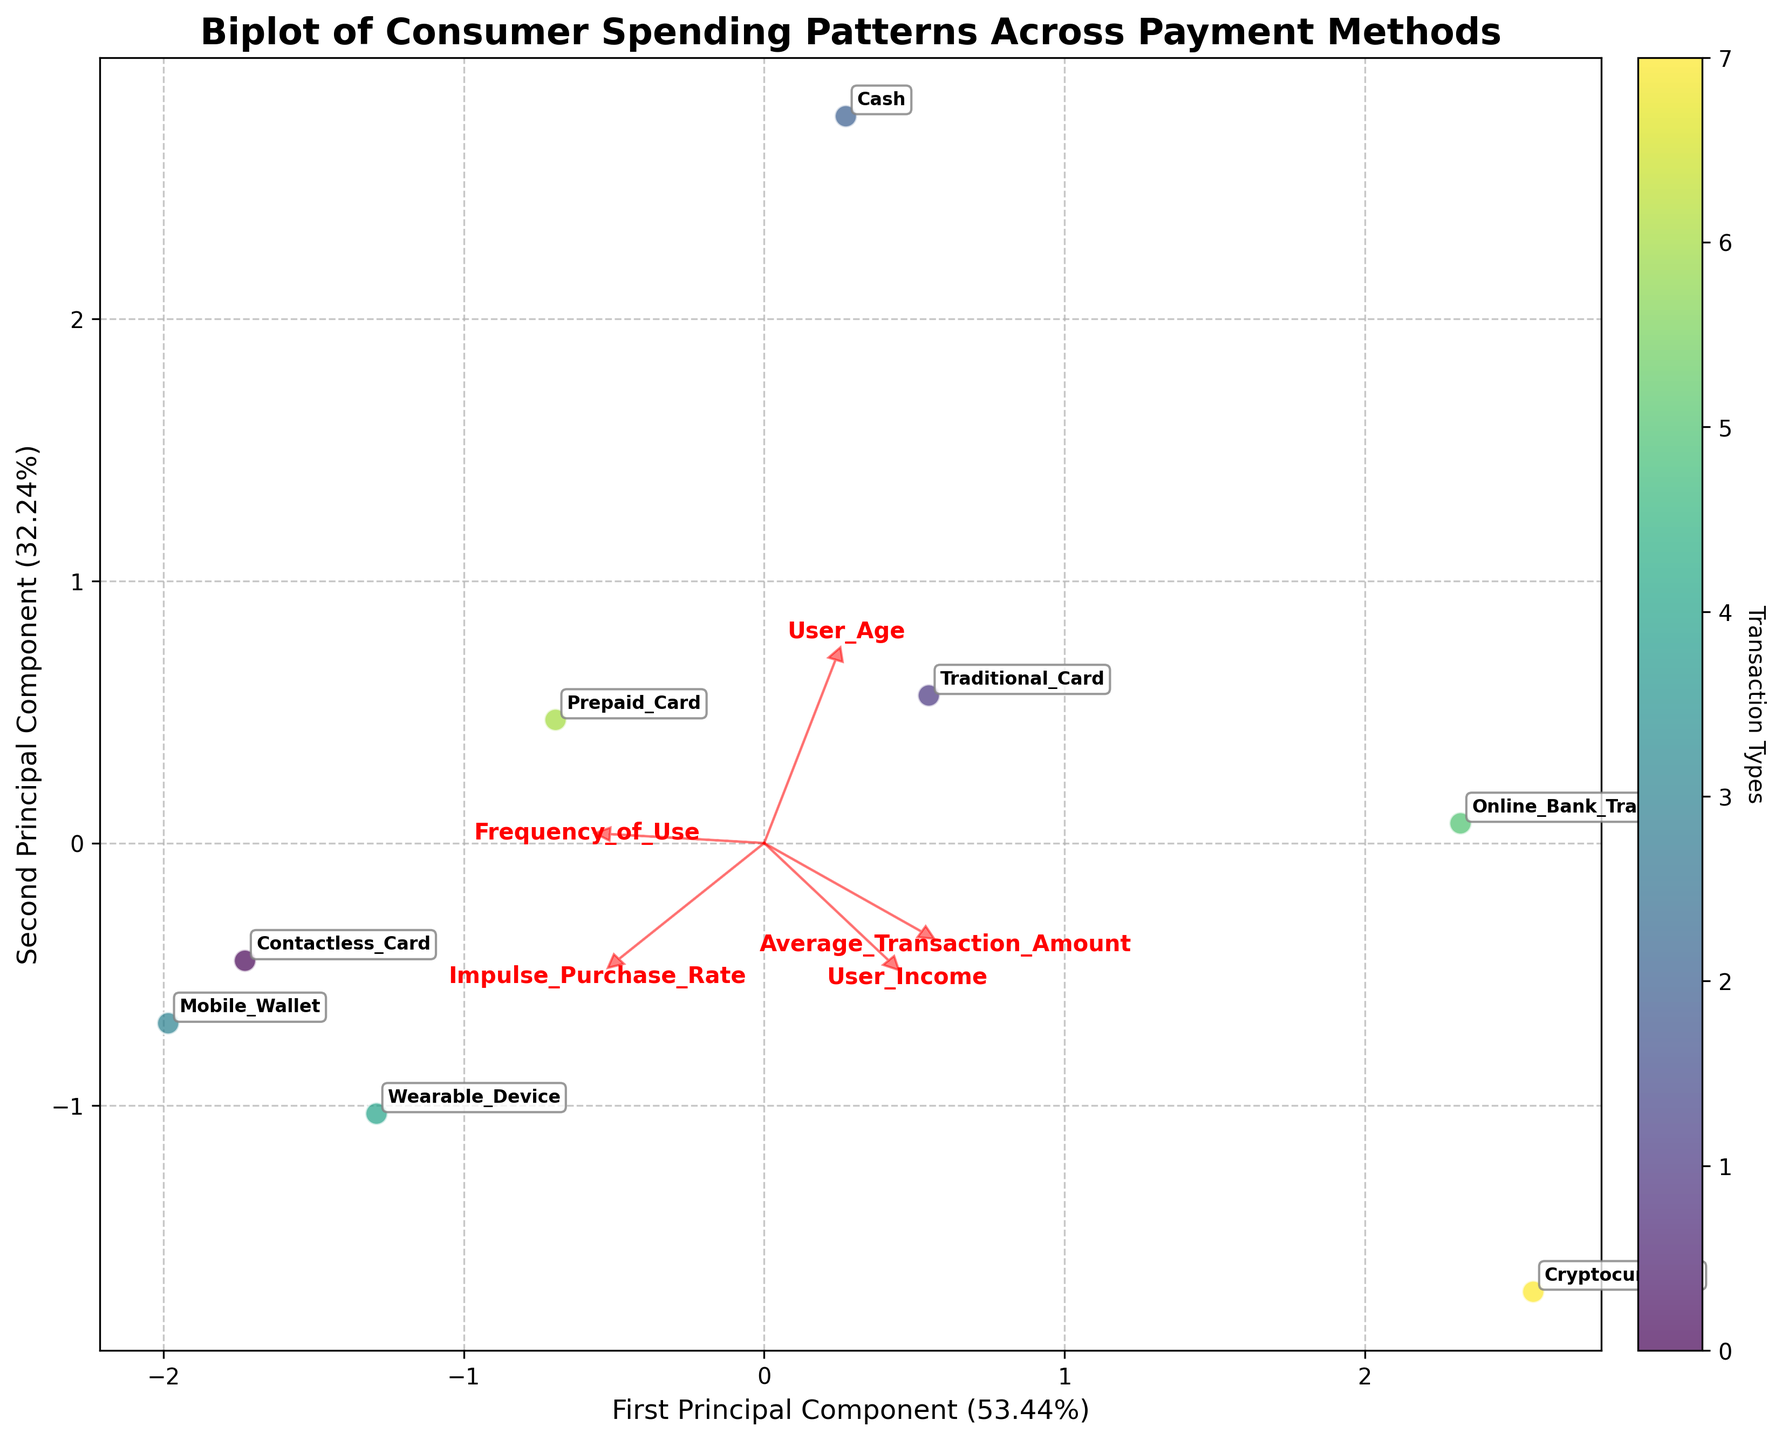How many principal components are displayed in the biplot? The biplot shows two principal components, which is evident from the two axes labeled as 'First Principal Component' and 'Second Principal Component'.
Answer: Two Which payment method has the highest value on the first principal component? To find the payment method with the highest value on the first principal component, look at the x-axis for the furthest point to the right.
Answer: Cryptocurrency What is the range of the impulse purchase rate based on the feature vectors in the biplot? The impulse purchase rate vector originates from the center and points in a specific direction. Observing the length and direction gives an idea of the range covered by the vector.
Answer: From -0.35 to 0.35 Which two payment methods have the smallest Euclidean distance between their principal component scores? Check the proximity of the points representing different payment methods. The pairs of points closest to each other represent those with the smallest Euclidean distance.
Answer: Contactless Card and Mobile Wallet How does user age correlate with the first principal component? Correlation can be inferred from the direction and proximity of the user age feature vector relative to the first principal component axis.
Answer: Inversely related Between contactless card and traditional card, which has a higher frequency of use? Locate the points for contactless card and traditional card. Then, refer to the frequency of use feature vector to see which point aligns more closely with a higher value.
Answer: Contactless Card Which feature has the least influence on the second principal component? Check the arrow lengths of the feature vectors; the shorter the arrow on the second principal component axis, the lesser its influence.
Answer: User Income What does a higher impulse purchase rate imply about the type of payment method used? Look for the relationship between payment methods and the impulse purchase rate vector. Identify clusters or trends related to higher values.
Answer: More likely to be contactless or mobile Is there any payment method that features prominently along both principal components? If so, which one? Identify any points that are extreme along both the x and y axes, relative to the spread of other points.
Answer: Cryptocurrency Which method stands out for having high user income but a low frequency of use? Find the points aligned closely with high values for user income and cross-reference them with the frequency of use vector to spot discrepancies.
Answer: Online Bank Transfer 